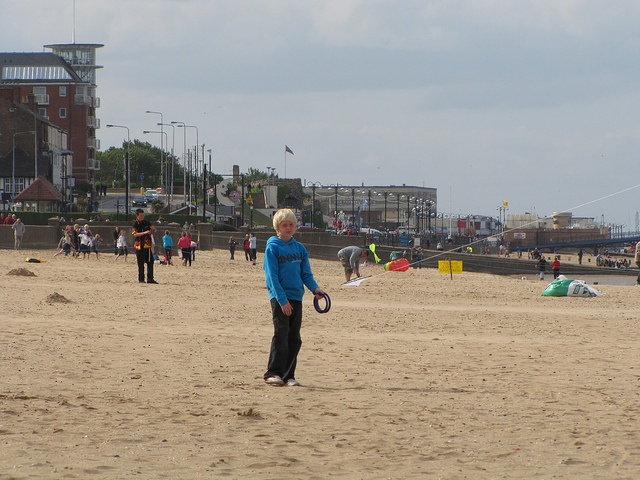Describe the objects in this image and their specific colors. I can see people in lightgray, gray, black, darkgray, and tan tones, people in lightgray, black, blue, and darkblue tones, people in lightgray, black, maroon, and gray tones, kite in lightgray, teal, darkgray, and gray tones, and people in lightgray, gray, maroon, darkgray, and black tones in this image. 